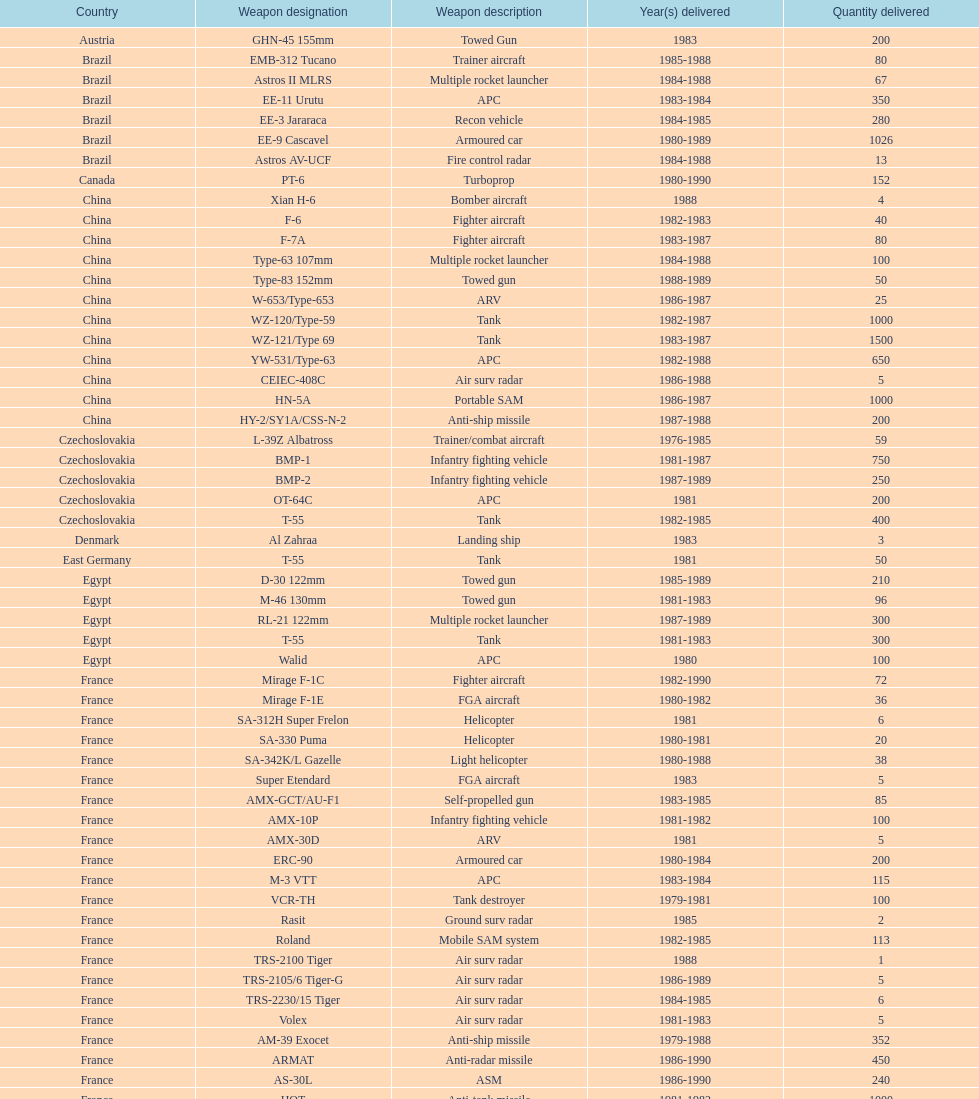In which country did iraq initially purchase weapons from? Czechoslovakia. 